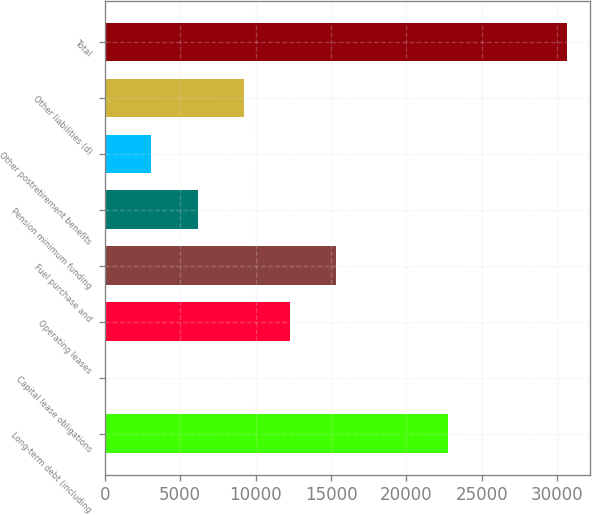<chart> <loc_0><loc_0><loc_500><loc_500><bar_chart><fcel>Long-term debt (including<fcel>Capital lease obligations<fcel>Operating leases<fcel>Fuel purchase and<fcel>Pension minimum funding<fcel>Other postretirement benefits<fcel>Other liabilities (d)<fcel>Total<nl><fcel>22772<fcel>16<fcel>12276.4<fcel>15341.5<fcel>6146.2<fcel>3081.1<fcel>9211.3<fcel>30667<nl></chart> 